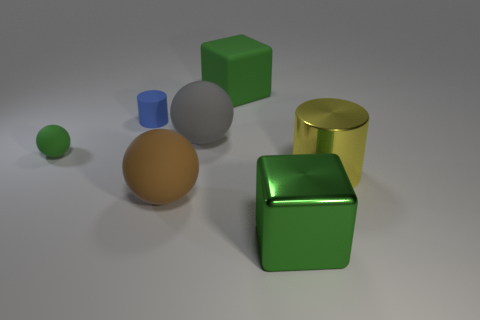What materials do these objects appear to be made of based on their appearance? The objects have different textures and sheens suggesting various materials: the small green sphere and large cube seem to be rubbery due to their matte and slightly muted surfaces; the blue cylinder and yellow cylinder have high-gloss finishes indicative of metallic materials; and the brown ball and grey sphere have a diffused reflectivity, resembling matte painted surfaces. 